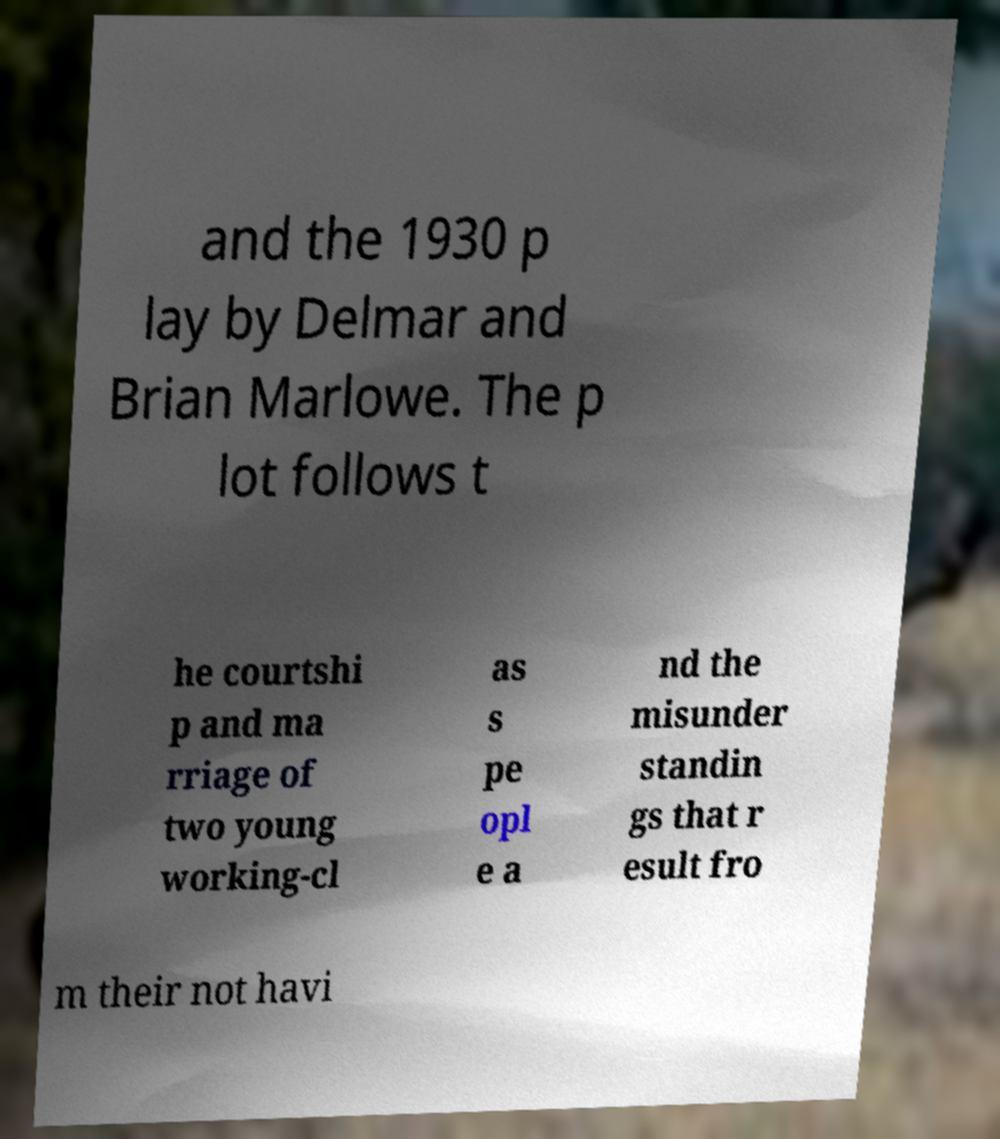What messages or text are displayed in this image? I need them in a readable, typed format. and the 1930 p lay by Delmar and Brian Marlowe. The p lot follows t he courtshi p and ma rriage of two young working-cl as s pe opl e a nd the misunder standin gs that r esult fro m their not havi 